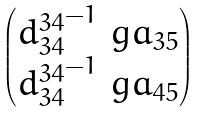<formula> <loc_0><loc_0><loc_500><loc_500>\begin{pmatrix} { d ^ { 3 4 } _ { 3 4 } } ^ { - 1 } \ g a _ { 3 5 } \\ { d ^ { 3 4 } _ { 3 4 } } ^ { - 1 } \ g a _ { 4 5 } \end{pmatrix}</formula> 